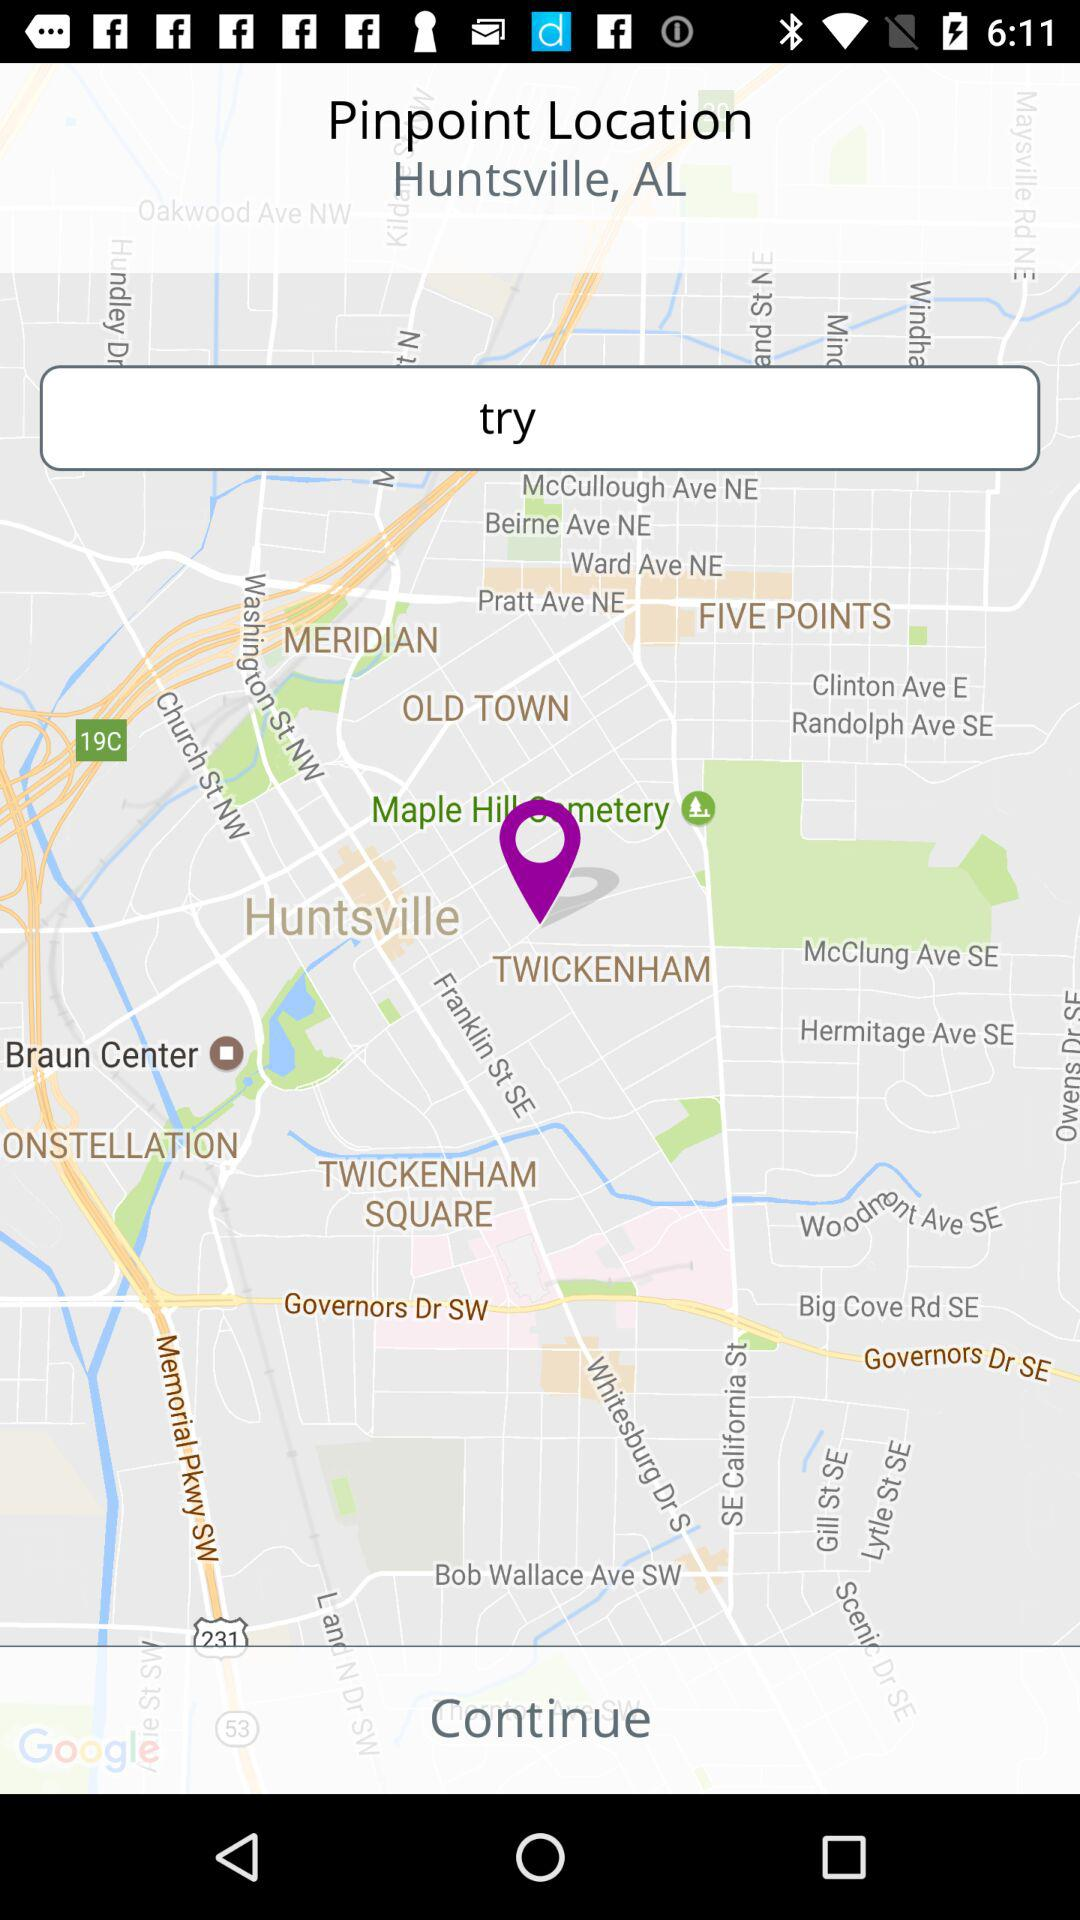How far away is Huntsville, AL?
When the provided information is insufficient, respond with <no answer>. <no answer> 